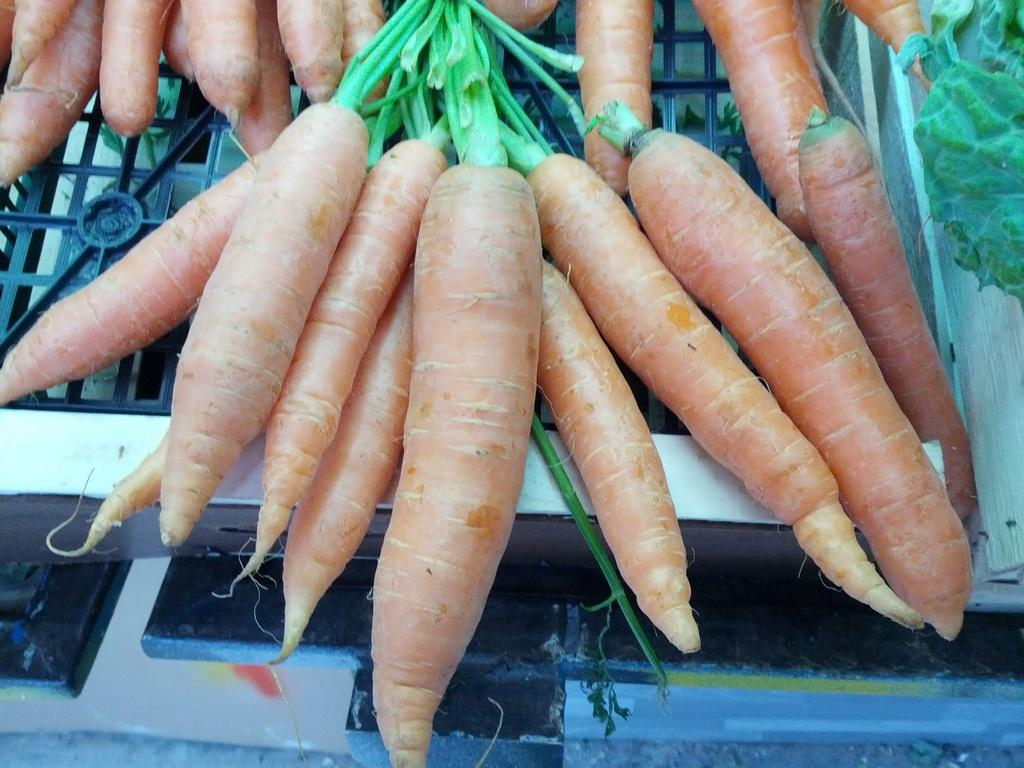What is the main subject of the image? The main subject of the image is carrots and green chilies. How are the carrots arranged in the image? The carrots are kept on a box. What is the color of the box containing the green chilies? The green chilies are kept on a white cotton box. Is there any liquid visible in the image? There might be water visible in the image. Can you see any geese or ducks in the image? There are no geese or ducks present in the image. What type of animal is interacting with the carrots in the image? There is no animal interacting with the carrots in the image; the carrots are simply placed on a box. 